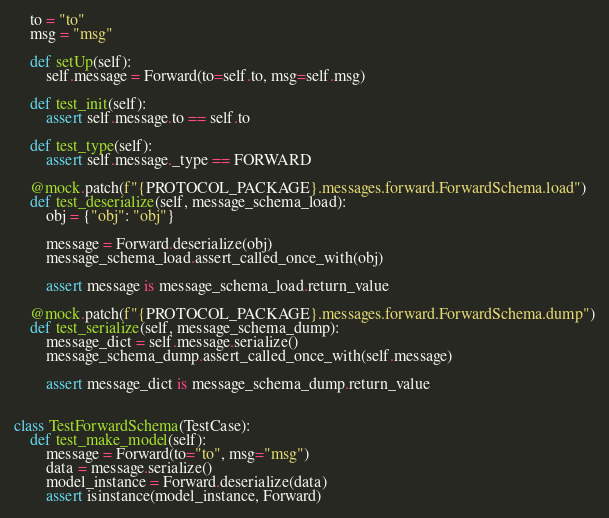<code> <loc_0><loc_0><loc_500><loc_500><_Python_>    to = "to"
    msg = "msg"

    def setUp(self):
        self.message = Forward(to=self.to, msg=self.msg)

    def test_init(self):
        assert self.message.to == self.to

    def test_type(self):
        assert self.message._type == FORWARD

    @mock.patch(f"{PROTOCOL_PACKAGE}.messages.forward.ForwardSchema.load")
    def test_deserialize(self, message_schema_load):
        obj = {"obj": "obj"}

        message = Forward.deserialize(obj)
        message_schema_load.assert_called_once_with(obj)

        assert message is message_schema_load.return_value

    @mock.patch(f"{PROTOCOL_PACKAGE}.messages.forward.ForwardSchema.dump")
    def test_serialize(self, message_schema_dump):
        message_dict = self.message.serialize()
        message_schema_dump.assert_called_once_with(self.message)

        assert message_dict is message_schema_dump.return_value


class TestForwardSchema(TestCase):
    def test_make_model(self):
        message = Forward(to="to", msg="msg")
        data = message.serialize()
        model_instance = Forward.deserialize(data)
        assert isinstance(model_instance, Forward)
</code> 